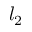Convert formula to latex. <formula><loc_0><loc_0><loc_500><loc_500>l _ { 2 }</formula> 